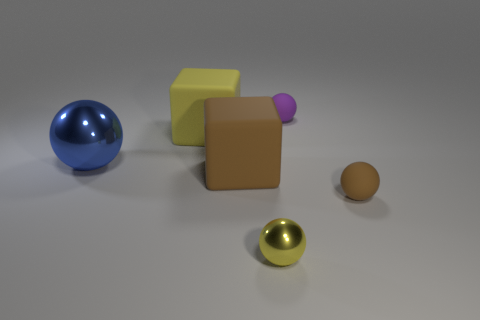Add 2 tiny cylinders. How many objects exist? 8 Subtract all blocks. How many objects are left? 4 Add 4 tiny brown balls. How many tiny brown balls are left? 5 Add 2 large yellow rubber objects. How many large yellow rubber objects exist? 3 Subtract 0 green cylinders. How many objects are left? 6 Subtract all tiny yellow matte blocks. Subtract all big blue shiny things. How many objects are left? 5 